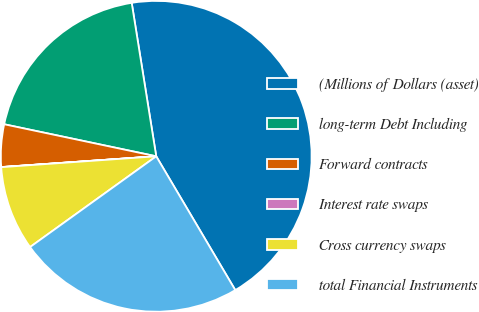<chart> <loc_0><loc_0><loc_500><loc_500><pie_chart><fcel>(Millions of Dollars (asset)<fcel>long-term Debt Including<fcel>Forward contracts<fcel>Interest rate swaps<fcel>Cross currency swaps<fcel>total Financial Instruments<nl><fcel>44.03%<fcel>19.17%<fcel>4.41%<fcel>0.01%<fcel>8.81%<fcel>23.57%<nl></chart> 